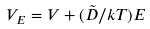<formula> <loc_0><loc_0><loc_500><loc_500>V _ { E } = V + ( \tilde { D } / k T ) E</formula> 